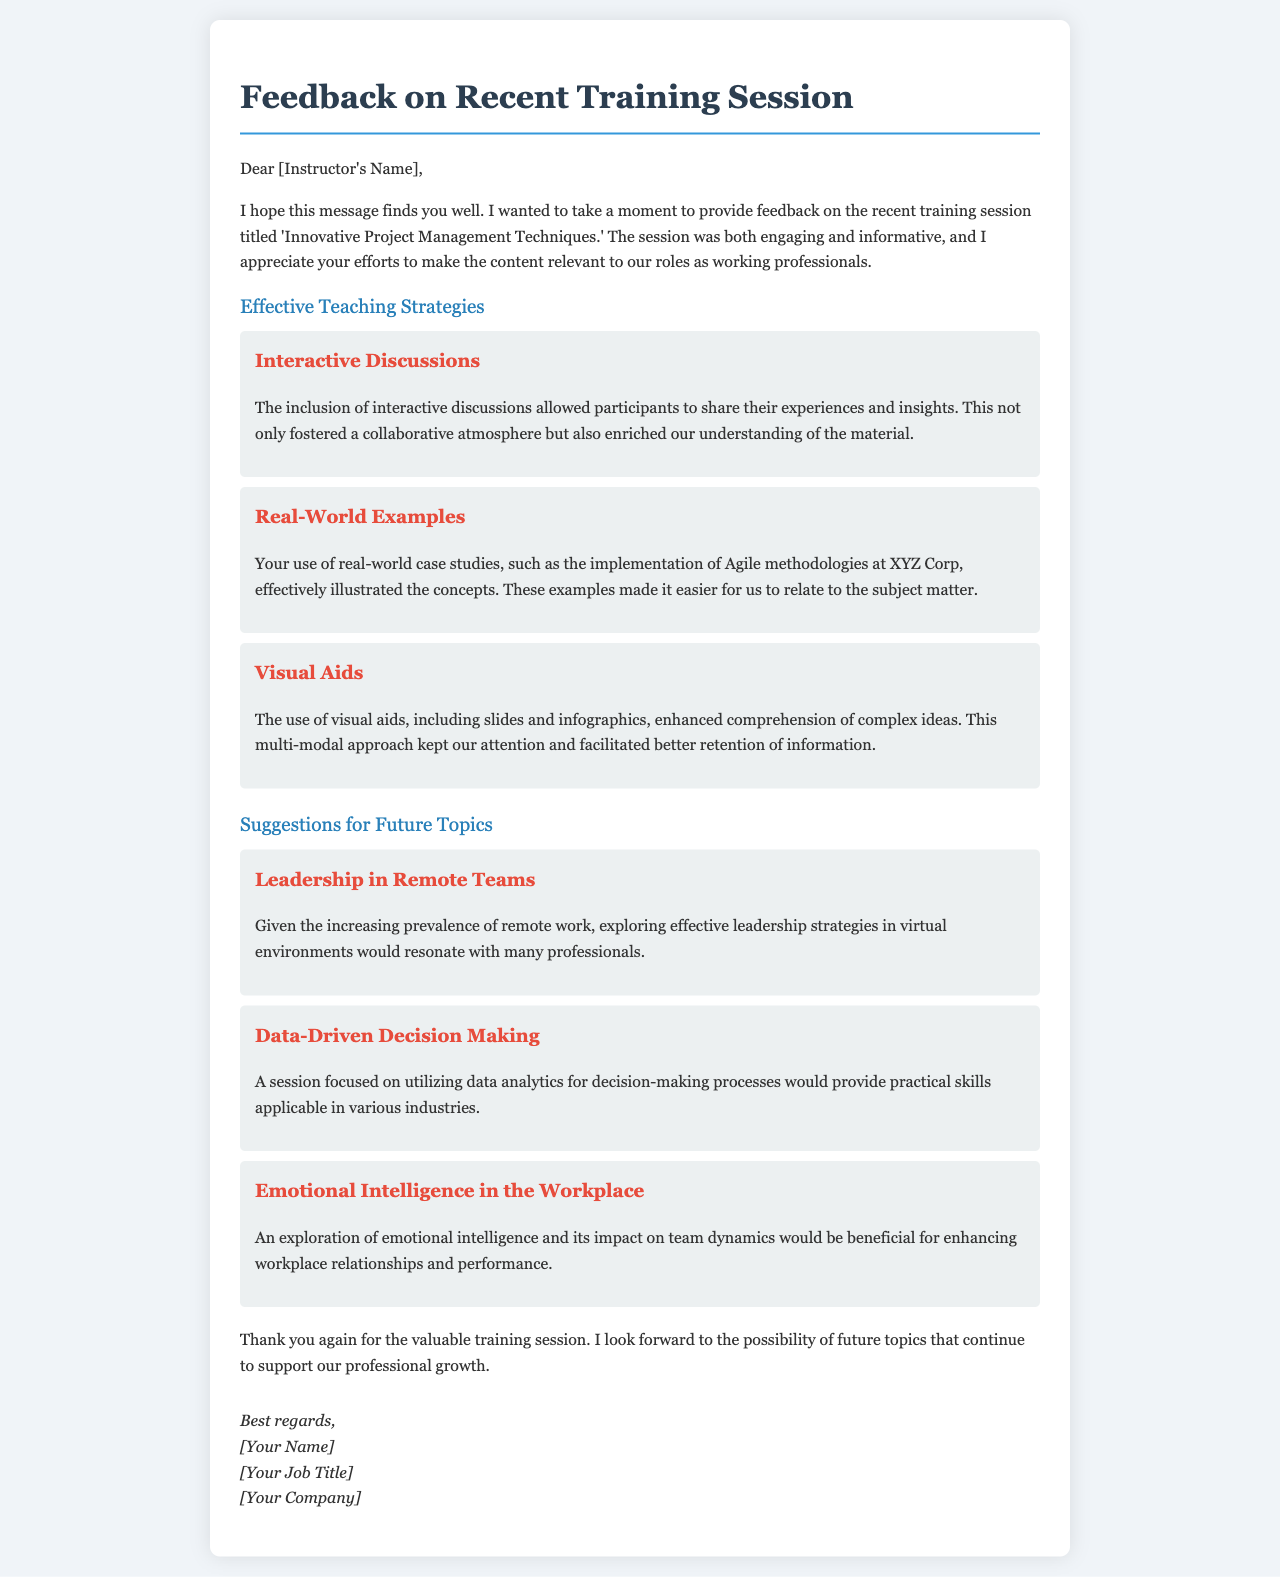What was the title of the training session? The title of the training session is mentioned in the introductory paragraph of the document.
Answer: Innovative Project Management Techniques Who is the feedback addressed to? The feedback letter starts by addressing the instructor, which is confirmed in the salutation.
Answer: [Instructor's Name] What is one effective teaching strategy mentioned in the document? The document includes a section detailing effective teaching strategies utilized during the training session.
Answer: Interactive Discussions How many suggestions for future topics are provided? The section on suggestions lists three distinct topics for future training sessions.
Answer: 3 What is one suggestion for a future topic? Each suggestion is clearly outlined in the document, with various topics listed for consideration.
Answer: Leadership in Remote Teams How did the instructor enhance comprehension of complex ideas? The document mentions specific methods used during the session to improve understanding of the material.
Answer: Visual Aids What is the profession of the feedback provider? The sign-off and context of the letter reveal the role of the provider in relation to the training.
Answer: [Your Job Title] In what kind of environment is the suggestion "Leadership in Remote Teams" applicable? The reasoning behind the suggestion indicates a specific trend in the working environment that is discussed earlier in the document.
Answer: Remote work 